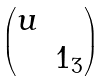Convert formula to latex. <formula><loc_0><loc_0><loc_500><loc_500>\begin{pmatrix} u & \\ & { 1 } _ { 3 } \end{pmatrix}</formula> 